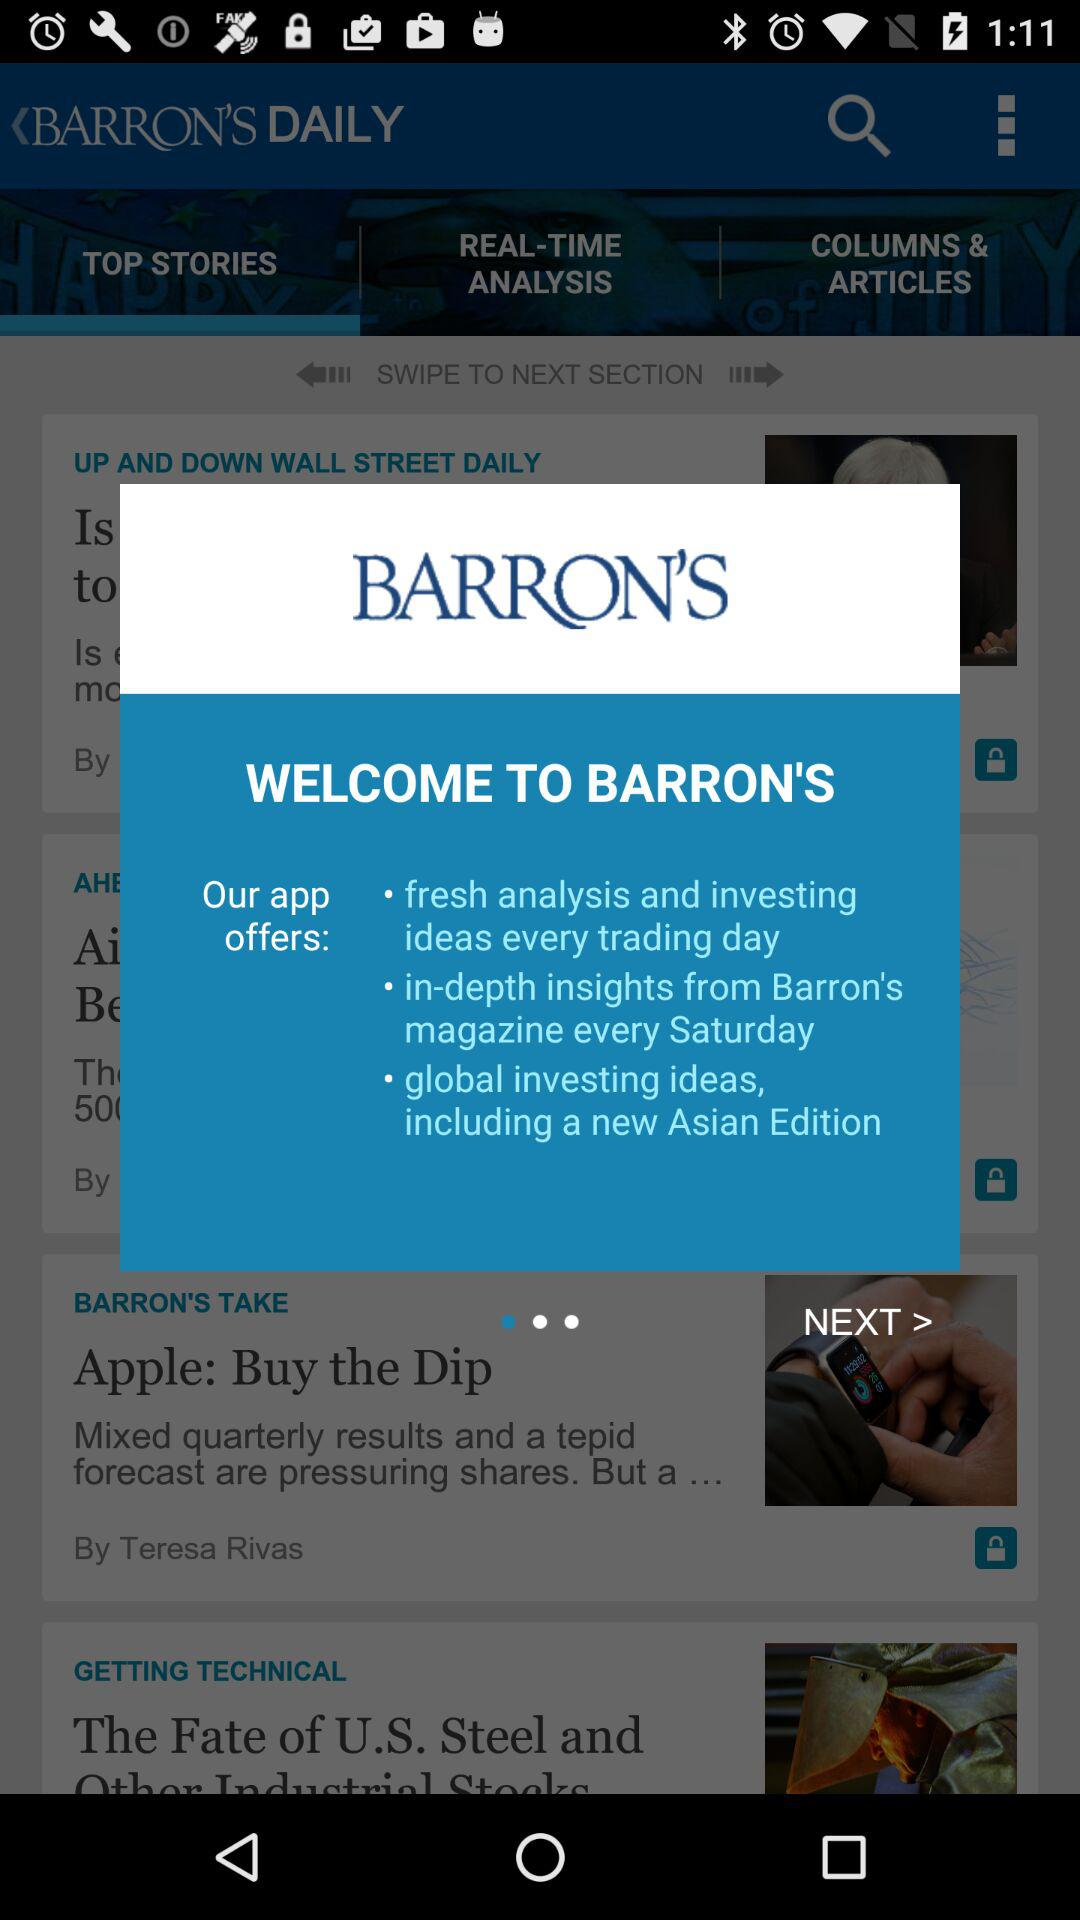When was "Apple: Buy the Dip" posted?
When the provided information is insufficient, respond with <no answer>. <no answer> 